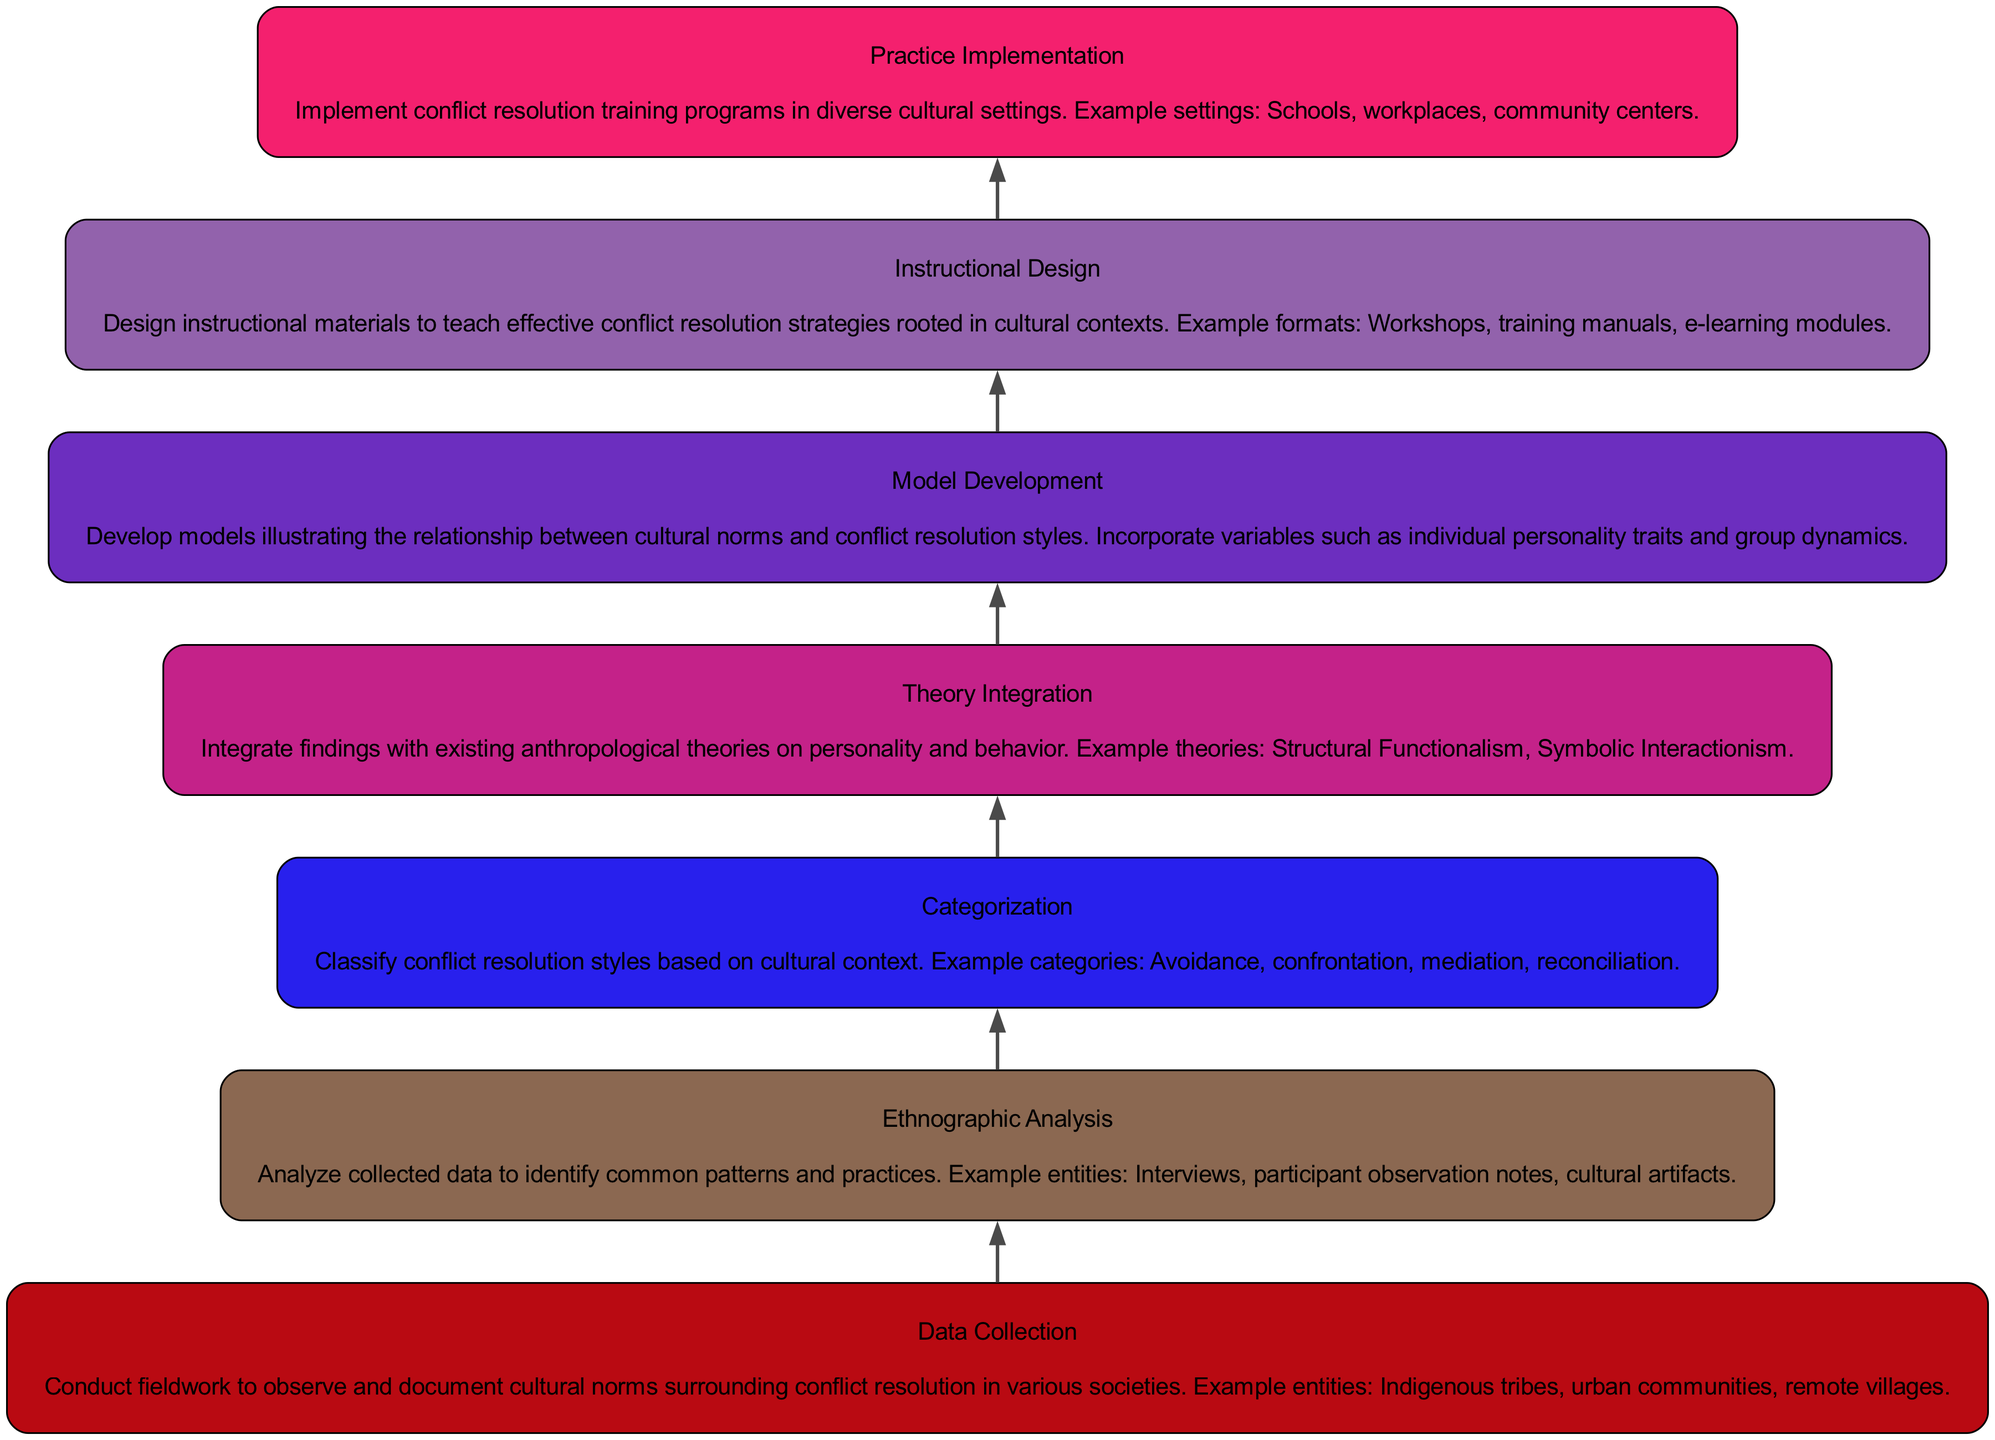What is the first stage in the flow? The flow chart starts from the bottom with the first stage labeled "Data Collection," which is the initial step in the process.
Answer: Data Collection How many nodes are present in the diagram? The diagram has a total of seven nodes, each representing a different stage in the process from data collection to practice implementation.
Answer: 7 What stage follows "Categorization"? The node representing the stage that follows "Categorization" is "Theory Integration", indicating the next step after classifying conflict resolution styles.
Answer: Theory Integration Which stage involves developing instructional materials? The stage focused on developing instructional materials is "Instructional Design", which emphasizes creating resources for teaching conflict resolution strategies.
Answer: Instructional Design What is the last stage of the flow? The final stage of the flow, positioned at the top, is "Practice Implementation," indicating the actual application of the training programs developed in earlier stages.
Answer: Practice Implementation How is "Model Development" related to "Categorization"? "Model Development" builds on the classifications made in "Categorization" by incorporating identified styles into models that show relationships, thus they are sequentially connected.
Answer: Sequentially connected What type of analysis is performed after data collection? After data collection, "Ethnographic Analysis" is conducted to interpret and identify patterns in the gathered cultural norms related to conflict resolution.
Answer: Ethnographic Analysis Which theory integrates with the findings after categorization? The findings after categorization are integrated with existing anthropological theories, particularly "Structural Functionalism" and "Symbolic Interactionism," enhancing theoretical understanding.
Answer: Structural Functionalism and Symbolic Interactionism What stage comes directly before "Practice Implementation"? The stage "Instructional Design" comes directly before "Practice Implementation," suggesting that effective teaching materials must be created prior to implementing training programs.
Answer: Instructional Design 